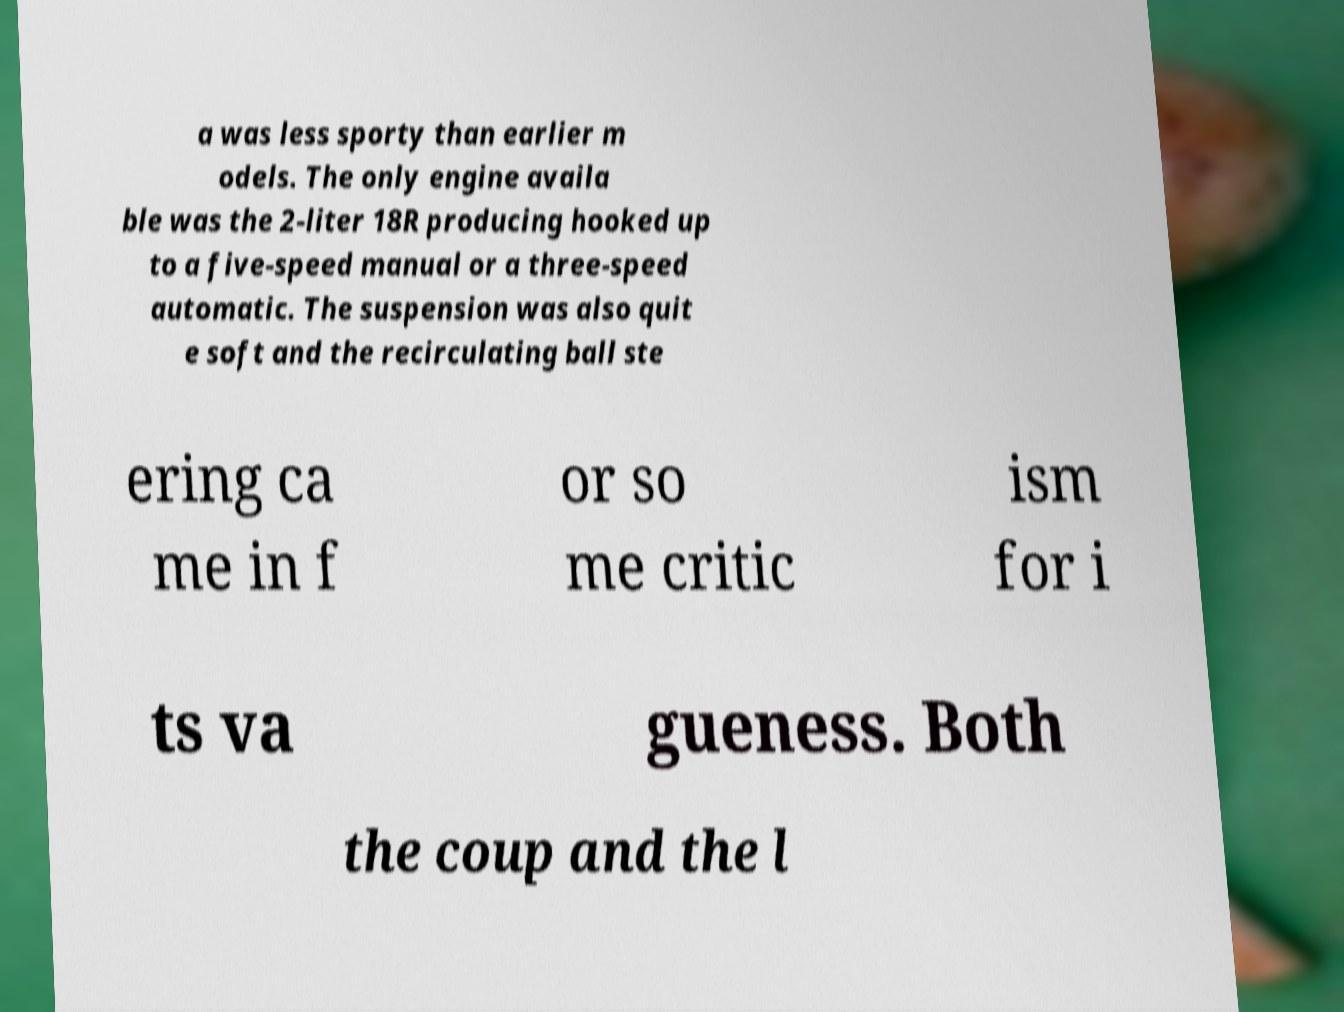I need the written content from this picture converted into text. Can you do that? a was less sporty than earlier m odels. The only engine availa ble was the 2-liter 18R producing hooked up to a five-speed manual or a three-speed automatic. The suspension was also quit e soft and the recirculating ball ste ering ca me in f or so me critic ism for i ts va gueness. Both the coup and the l 